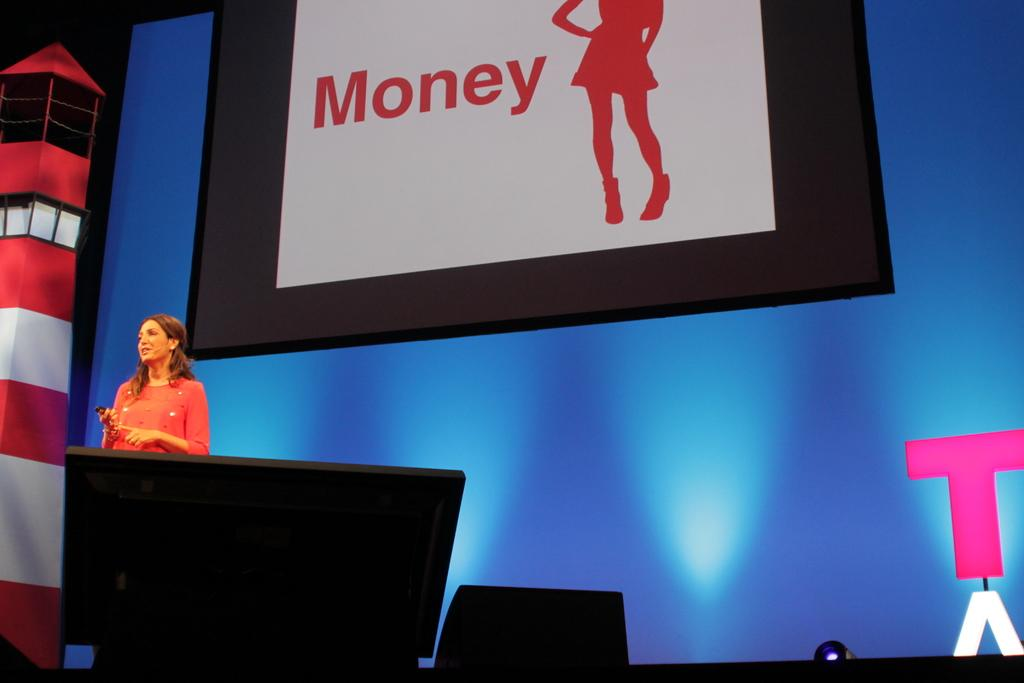<image>
Share a concise interpretation of the image provided. A woman giving a talk in front of a screen that says Money. 